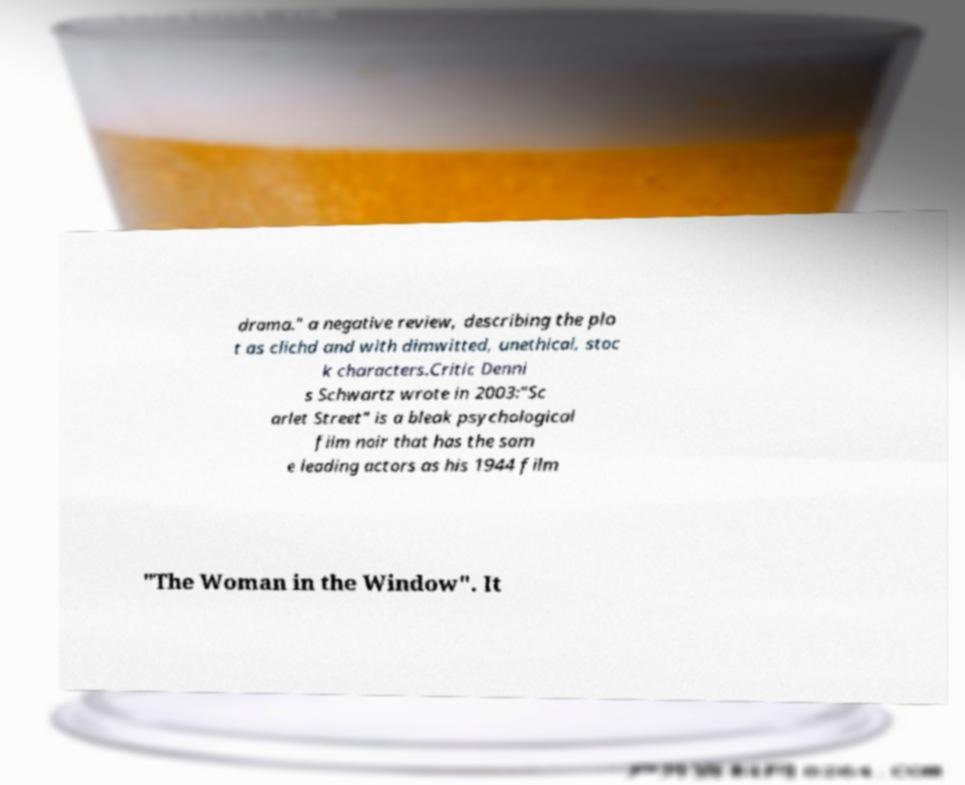For documentation purposes, I need the text within this image transcribed. Could you provide that? drama." a negative review, describing the plo t as clichd and with dimwitted, unethical, stoc k characters.Critic Denni s Schwartz wrote in 2003:"Sc arlet Street" is a bleak psychological film noir that has the sam e leading actors as his 1944 film "The Woman in the Window". It 